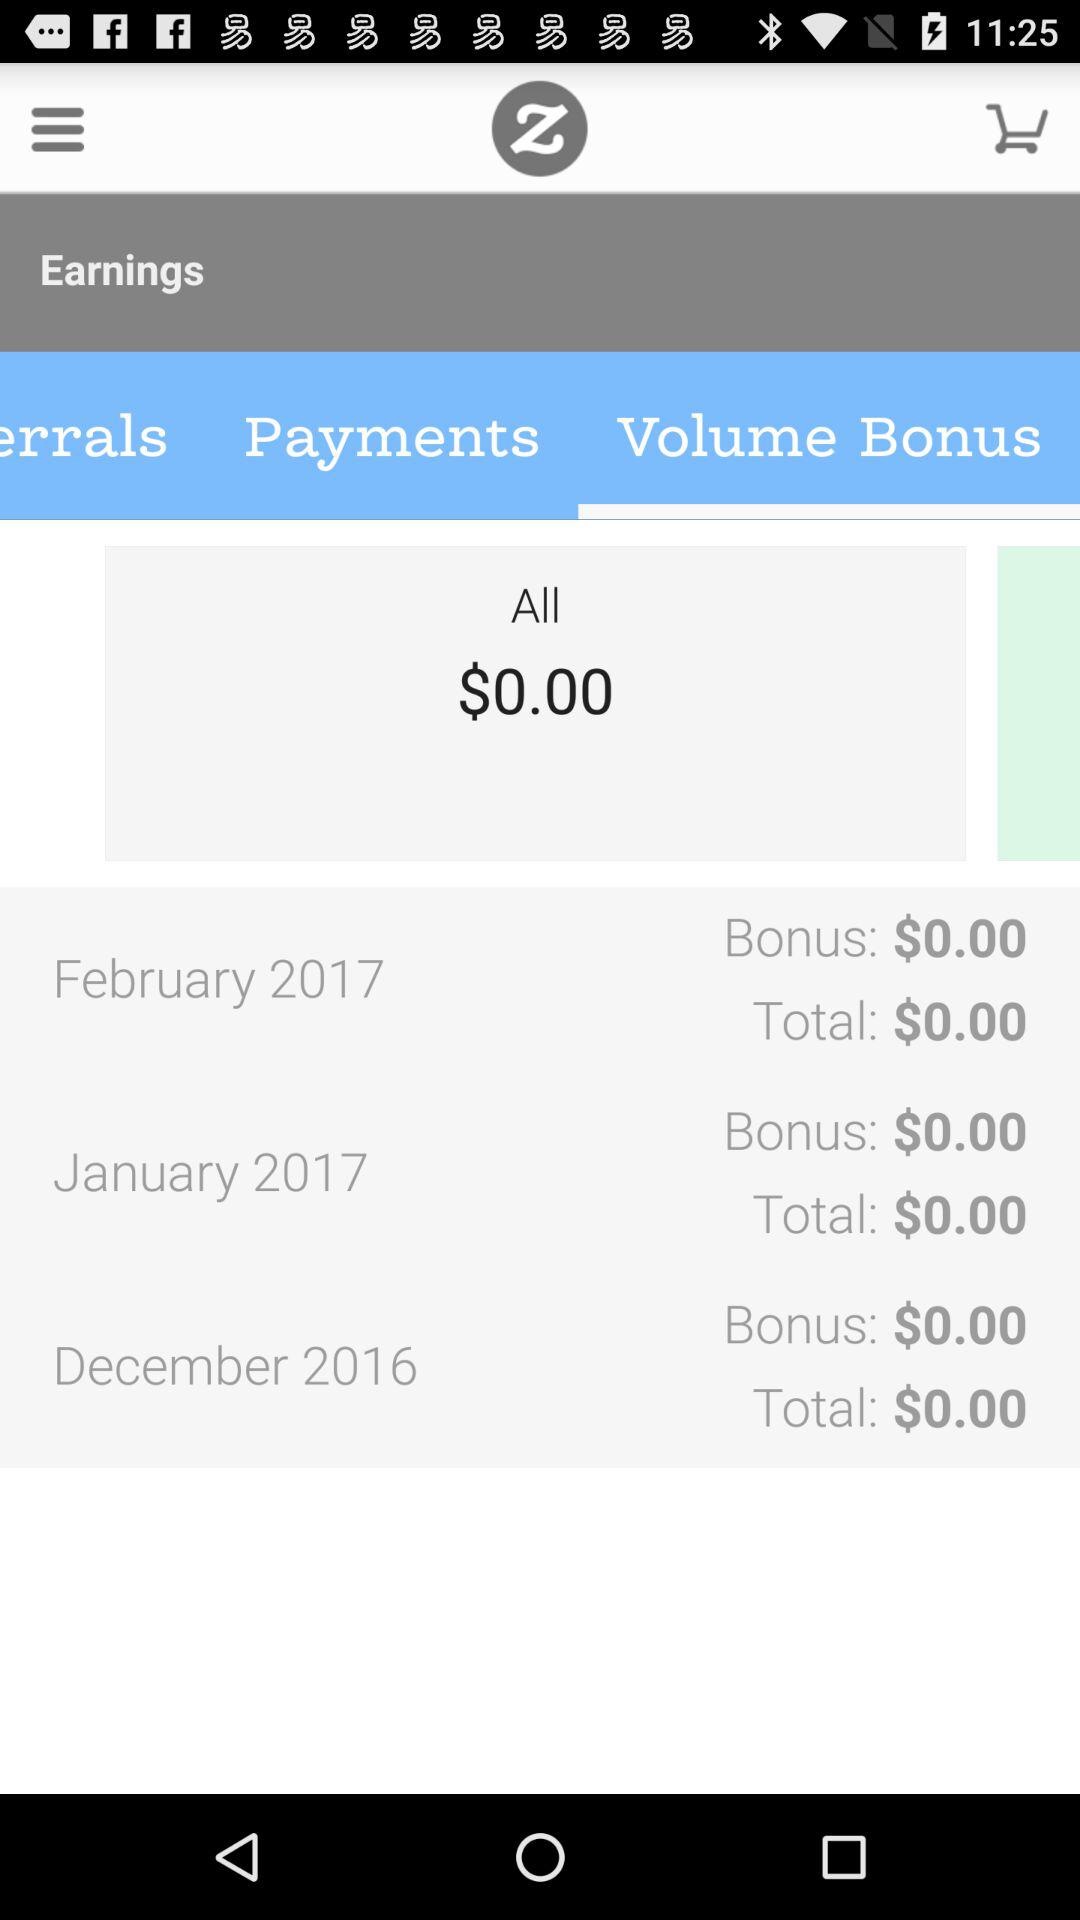What is the total amount of all the bonuses?
Answer the question using a single word or phrase. $0.00 